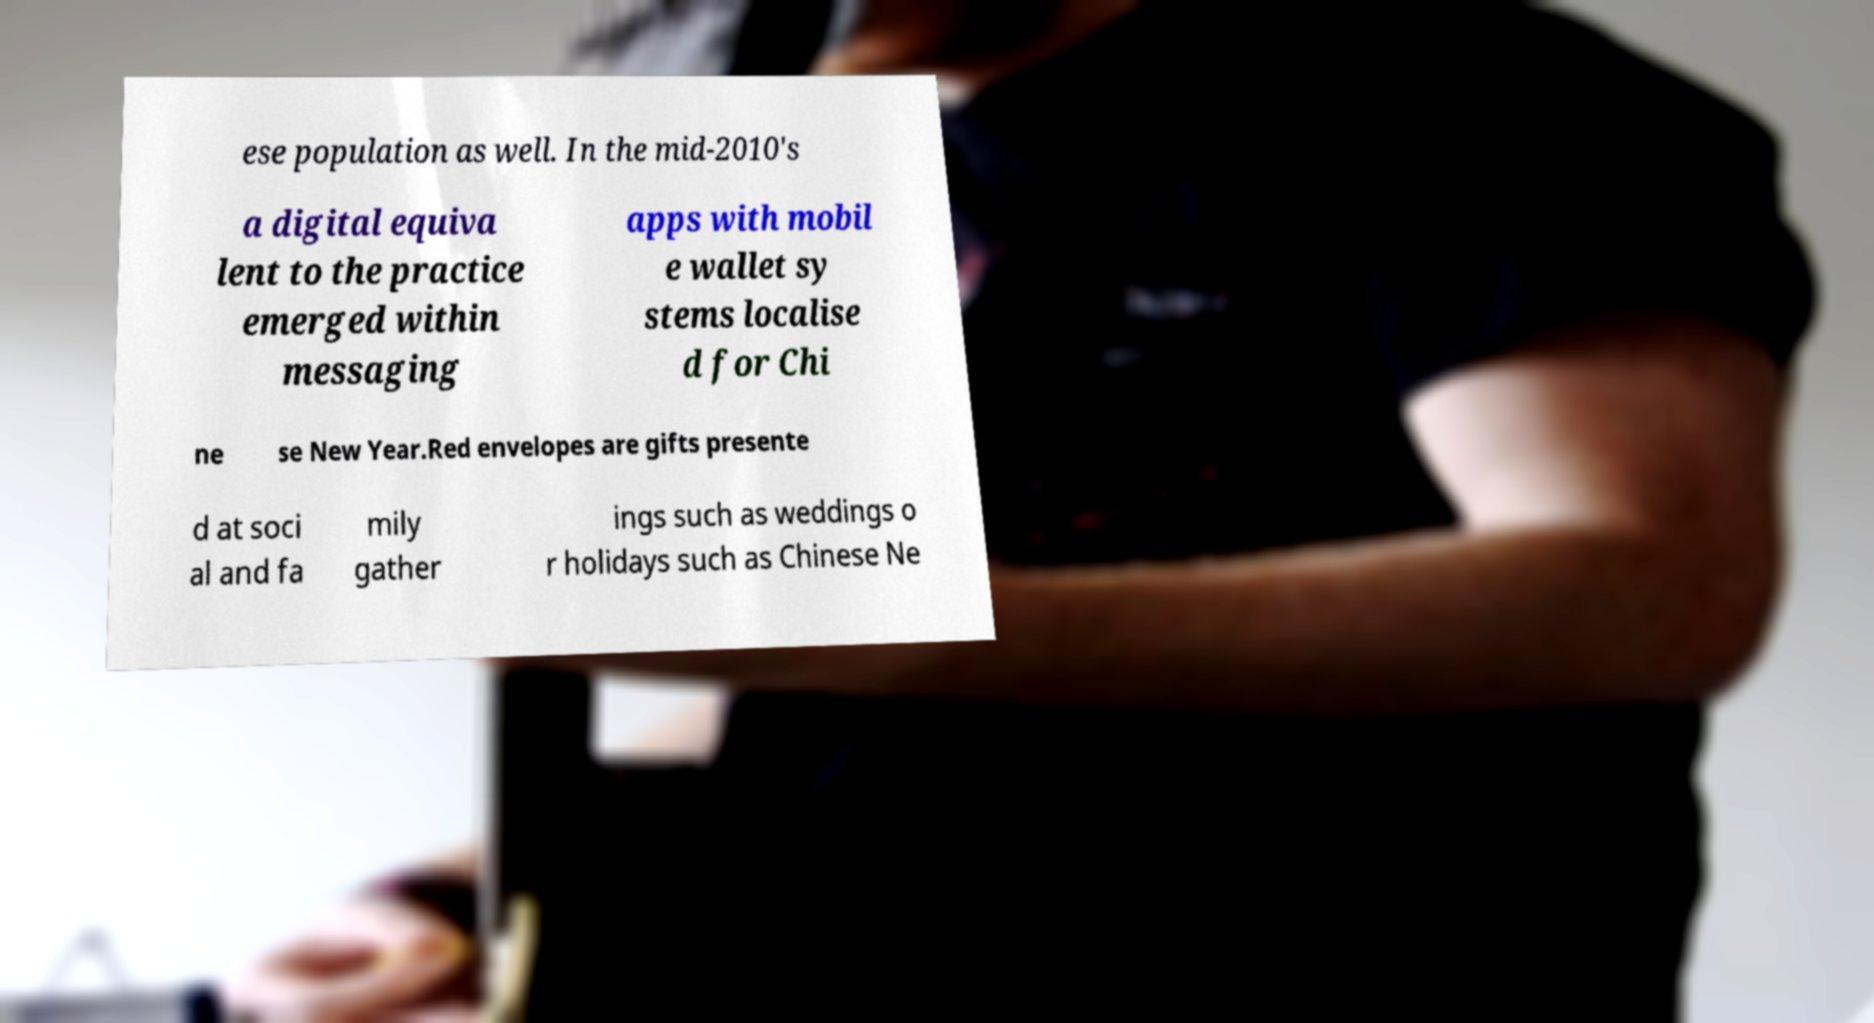For documentation purposes, I need the text within this image transcribed. Could you provide that? ese population as well. In the mid-2010's a digital equiva lent to the practice emerged within messaging apps with mobil e wallet sy stems localise d for Chi ne se New Year.Red envelopes are gifts presente d at soci al and fa mily gather ings such as weddings o r holidays such as Chinese Ne 